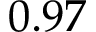Convert formula to latex. <formula><loc_0><loc_0><loc_500><loc_500>0 . 9 7</formula> 